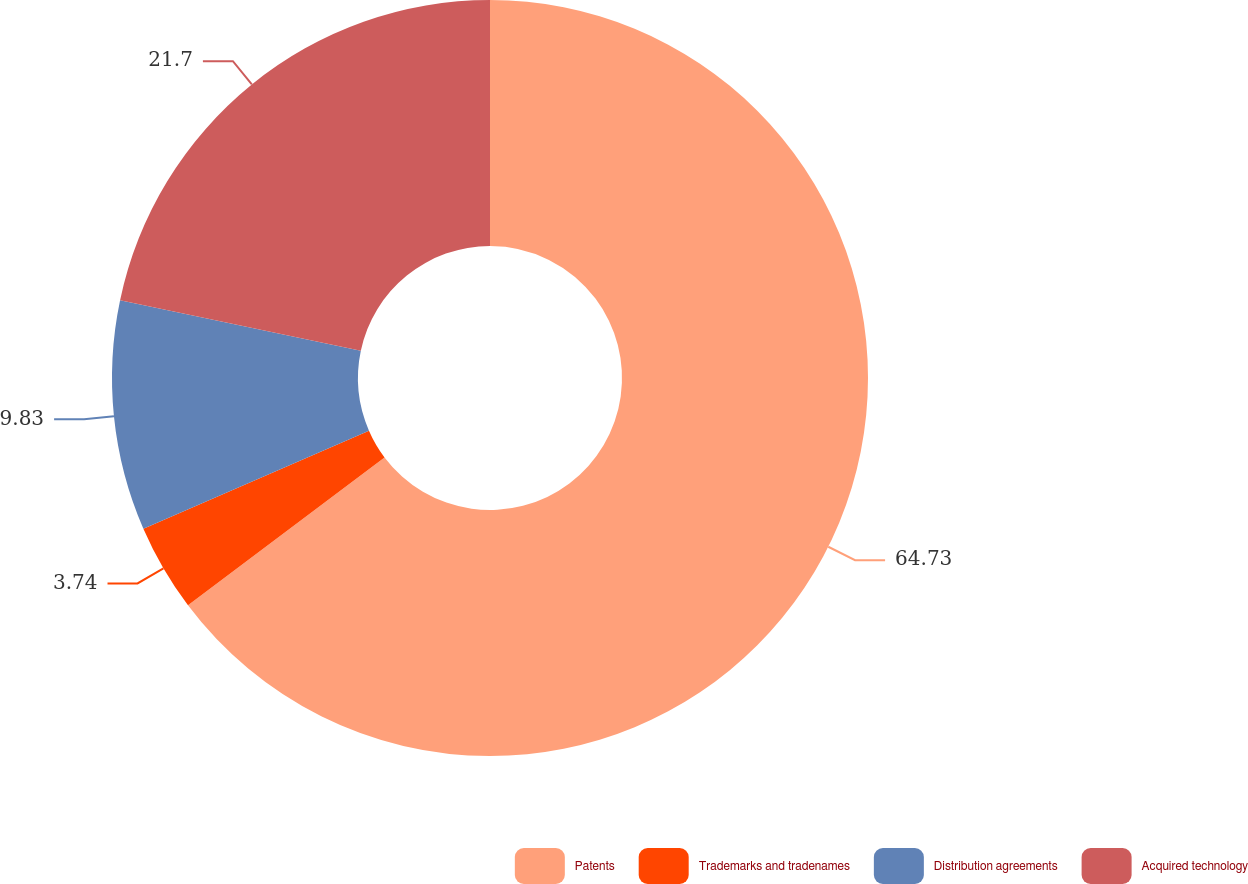<chart> <loc_0><loc_0><loc_500><loc_500><pie_chart><fcel>Patents<fcel>Trademarks and tradenames<fcel>Distribution agreements<fcel>Acquired technology<nl><fcel>64.73%<fcel>3.74%<fcel>9.83%<fcel>21.7%<nl></chart> 